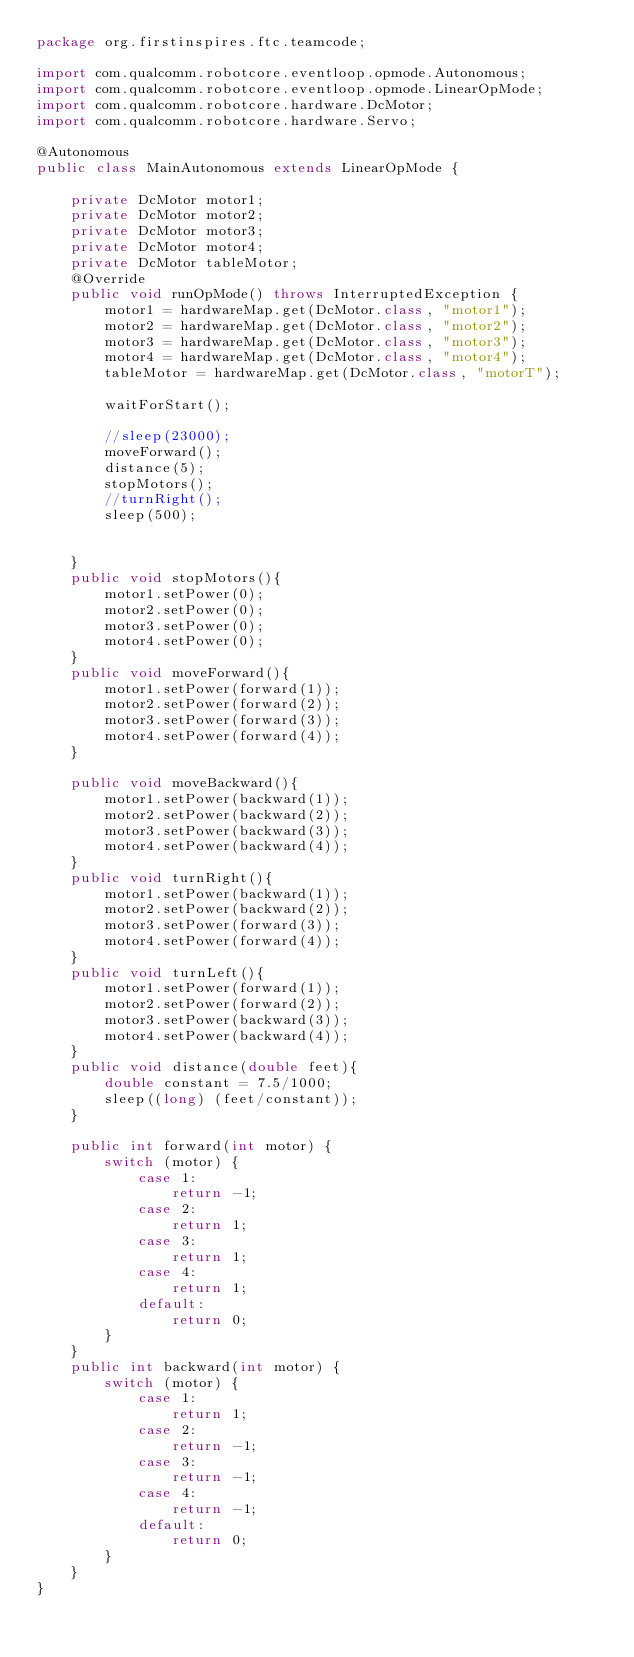<code> <loc_0><loc_0><loc_500><loc_500><_Java_>package org.firstinspires.ftc.teamcode;

import com.qualcomm.robotcore.eventloop.opmode.Autonomous;
import com.qualcomm.robotcore.eventloop.opmode.LinearOpMode;
import com.qualcomm.robotcore.hardware.DcMotor;
import com.qualcomm.robotcore.hardware.Servo;

@Autonomous
public class MainAutonomous extends LinearOpMode {

    private DcMotor motor1;
    private DcMotor motor2;
    private DcMotor motor3;
    private DcMotor motor4;
    private DcMotor tableMotor;
    @Override
    public void runOpMode() throws InterruptedException {
        motor1 = hardwareMap.get(DcMotor.class, "motor1");
        motor2 = hardwareMap.get(DcMotor.class, "motor2");
        motor3 = hardwareMap.get(DcMotor.class, "motor3");
        motor4 = hardwareMap.get(DcMotor.class, "motor4");
        tableMotor = hardwareMap.get(DcMotor.class, "motorT");

        waitForStart();

        //sleep(23000);
        moveForward();
        distance(5);
        stopMotors();
        //turnRight();
        sleep(500);


    }
    public void stopMotors(){
        motor1.setPower(0);
        motor2.setPower(0);
        motor3.setPower(0);
        motor4.setPower(0);
    }
    public void moveForward(){
        motor1.setPower(forward(1));
        motor2.setPower(forward(2));
        motor3.setPower(forward(3));
        motor4.setPower(forward(4));
    }

    public void moveBackward(){
        motor1.setPower(backward(1));
        motor2.setPower(backward(2));
        motor3.setPower(backward(3));
        motor4.setPower(backward(4));
    }
    public void turnRight(){
        motor1.setPower(backward(1));
        motor2.setPower(backward(2));
        motor3.setPower(forward(3));
        motor4.setPower(forward(4));
    }
    public void turnLeft(){
        motor1.setPower(forward(1));
        motor2.setPower(forward(2));
        motor3.setPower(backward(3));
        motor4.setPower(backward(4));
    }
    public void distance(double feet){
        double constant = 7.5/1000;
        sleep((long) (feet/constant));
    }

    public int forward(int motor) {
        switch (motor) {
            case 1:
                return -1;
            case 2:
                return 1;
            case 3:
                return 1;
            case 4:
                return 1;
            default:
                return 0;
        }
    }
    public int backward(int motor) {
        switch (motor) {
            case 1:
                return 1;
            case 2:
                return -1;
            case 3:
                return -1;
            case 4:
                return -1;
            default:
                return 0;
        }
    }
}

</code> 